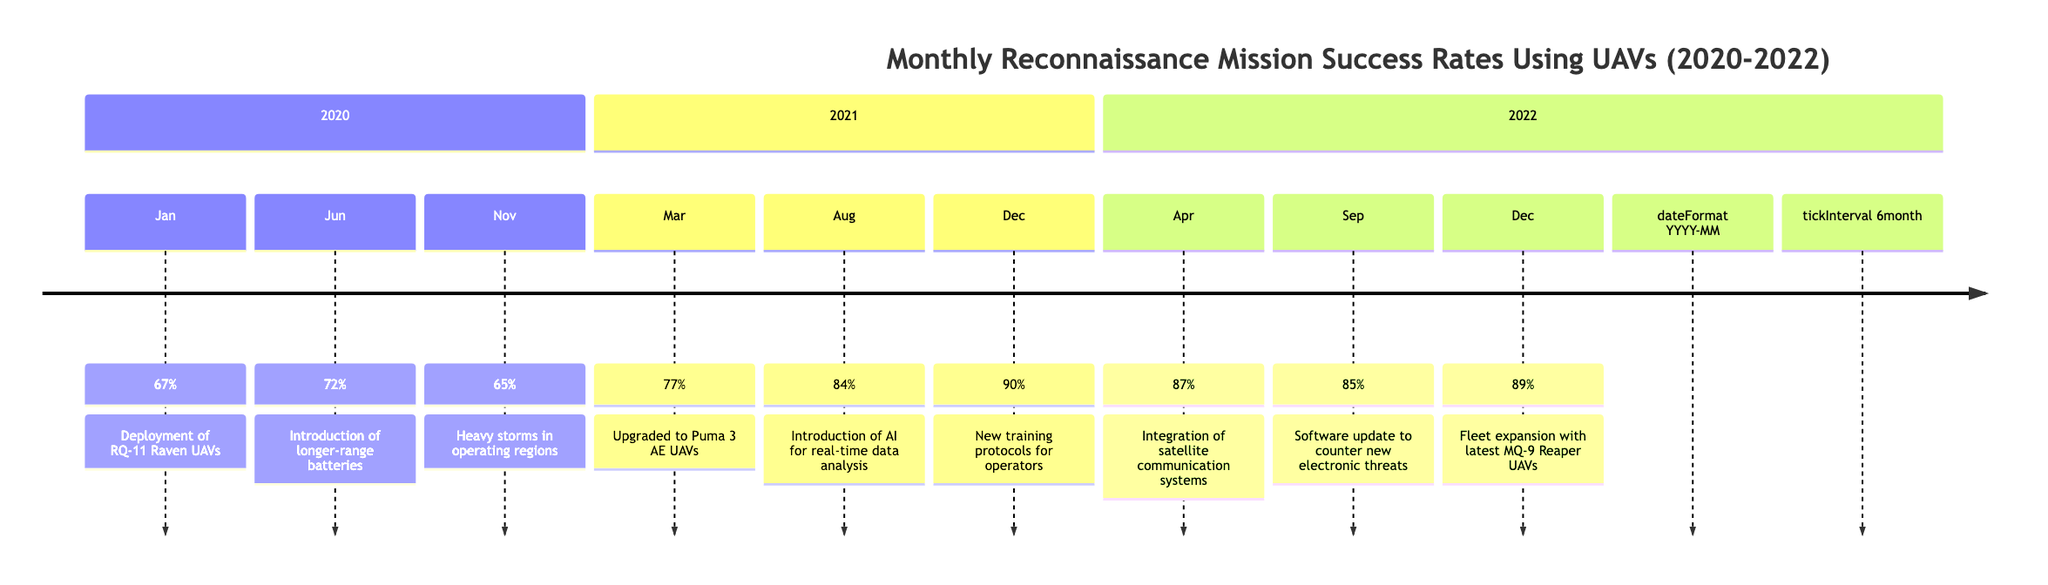What was the mission success rate in June 2020? The diagram shows a specific node for June 2020, which states that the mission success rate during that month was 72%.
Answer: 72% What notable event occurred in March 2021? According to the timeline, March 2021 had the notable event of upgrading to Puma 3 AE UAVs, which is mentioned beside the success rate.
Answer: Upgraded to Puma 3 AE UAVs What was the highest mission success rate recorded in the timeline? Looking at the timeline, December 2021 shows the highest mission success rate of 90%, indicating that this was the maximum point in the data.
Answer: 90% Which month in 2022 had a mission success rate of 85%? The timeline indicates that in September 2022, the mission success rate registered at 85%.
Answer: September 2022 How did the introduction of AI in August 2021 affect the mission success rate? Reviewing the timeline, the introduction of AI for real-time data analysis in August 2021 corresponds with a higher mission success rate of 84%, which can be compared to the previous rate of 77% in March 2021.
Answer: Increased success rate What trend can be observed from January 2020 to December 2022 regarding mission success rates? Analyzing the timeline, there is a general upward trend in mission success rates over the entire period from January 2020 (67%) to December 2022 (89%), indicating improved performance.
Answer: Upward trend What was the impact of the new training protocols on mission success rates? The timeline states that in December 2021, after implementing new training protocols for operators, the mission success rate increased to 90%, suggesting a positive impact.
Answer: Positive impact What is the time interval between the introduction of satellite communication systems and fleet expansion with MQ-9 Reaper UAVs? The timeline shows that satellite communication systems were integrated in April 2022, and fleet expansion with MQ-9 Reaper UAVs occurred in December 2022, resulting in an 8-month interval between these events.
Answer: 8 months Which notable event in the timeline was associated with the lowest mission success rate? The timeline indicates that November 2020 had the lowest mission success rate at 65%, which coincided with heavy storms affecting operations.
Answer: Heavy storms in operating regions 